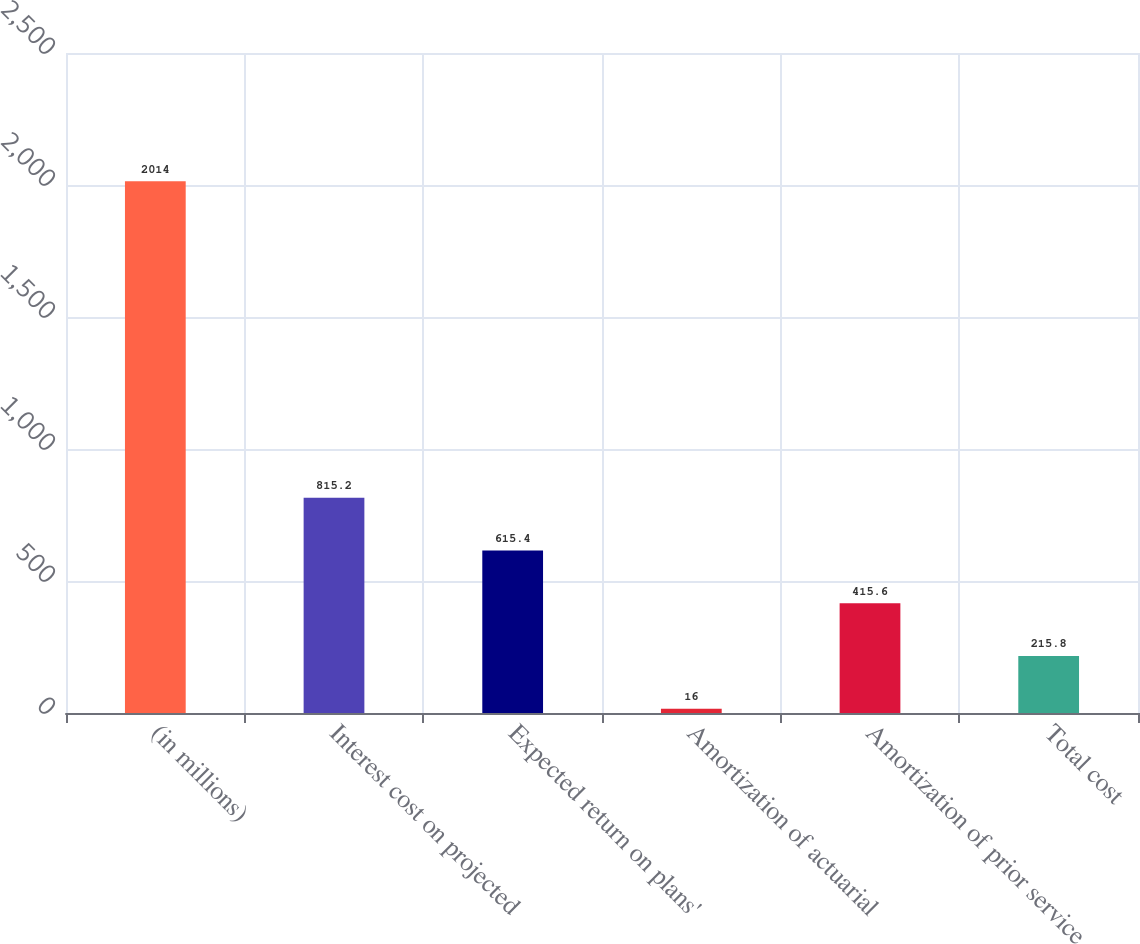Convert chart. <chart><loc_0><loc_0><loc_500><loc_500><bar_chart><fcel>(in millions)<fcel>Interest cost on projected<fcel>Expected return on plans'<fcel>Amortization of actuarial<fcel>Amortization of prior service<fcel>Total cost<nl><fcel>2014<fcel>815.2<fcel>615.4<fcel>16<fcel>415.6<fcel>215.8<nl></chart> 